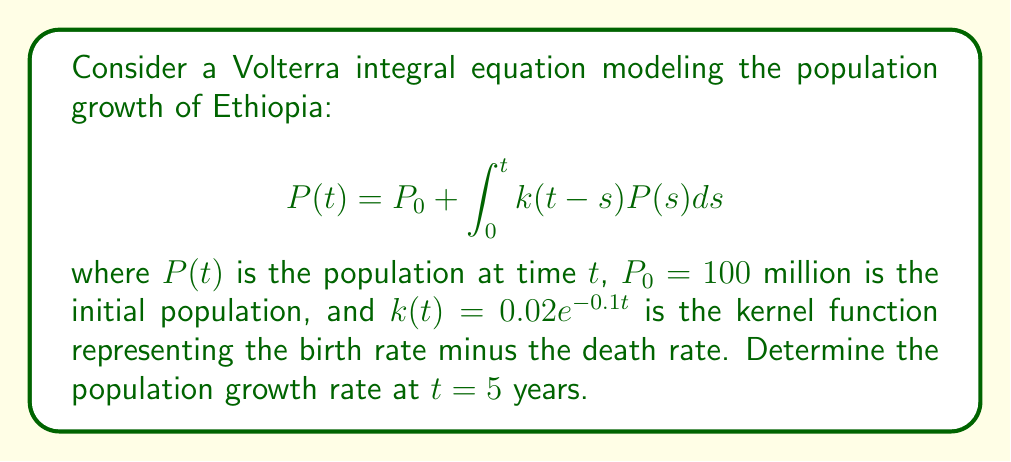Help me with this question. To solve this problem, we need to follow these steps:

1) The population growth rate is given by $\frac{dP}{dt}$. We can differentiate both sides of the Volterra equation with respect to $t$:

   $$\frac{dP}{dt} = k(0)P(t) + \int_0^t \frac{\partial k(t-s)}{\partial t}P(s)ds$$

2) We need to calculate $k(0)$ and $\frac{\partial k(t-s)}{\partial t}$:

   $k(0) = 0.02e^{-0.1 \cdot 0} = 0.02$

   $\frac{\partial k(t-s)}{\partial t} = 0.02 \cdot (-0.1) \cdot e^{-0.1(t-s)} = -0.002e^{-0.1(t-s)}$

3) Substituting these into the equation:

   $$\frac{dP}{dt} = 0.02P(t) - 0.002\int_0^t e^{-0.1(t-s)}P(s)ds$$

4) To evaluate this at $t=5$, we need $P(5)$. We can approximate this using the original equation:

   $$P(5) \approx P_0 + \int_0^5 0.02e^{-0.1(5-s)}P_0ds = 100 + 2\int_0^5 e^{-0.1(5-s)}ds$$

   $$= 100 + 2 \cdot \frac{1}{0.1}(1-e^{-0.5}) \approx 109.5 \text{ million}$$

5) Now we can evaluate the growth rate at $t=5$:

   $$\frac{dP}{dt}|_{t=5} = 0.02 \cdot 109.5 - 0.002\int_0^5 e^{-0.1(5-s)}109.5ds$$

   $$= 2.19 - 0.219\int_0^5 e^{-0.1(5-s)}ds = 2.19 - 0.219 \cdot \frac{1}{0.1}(1-e^{-0.5})$$

   $$\approx 2.19 - 1.95 = 0.24 \text{ million per year}$$
Answer: 0.24 million per year 